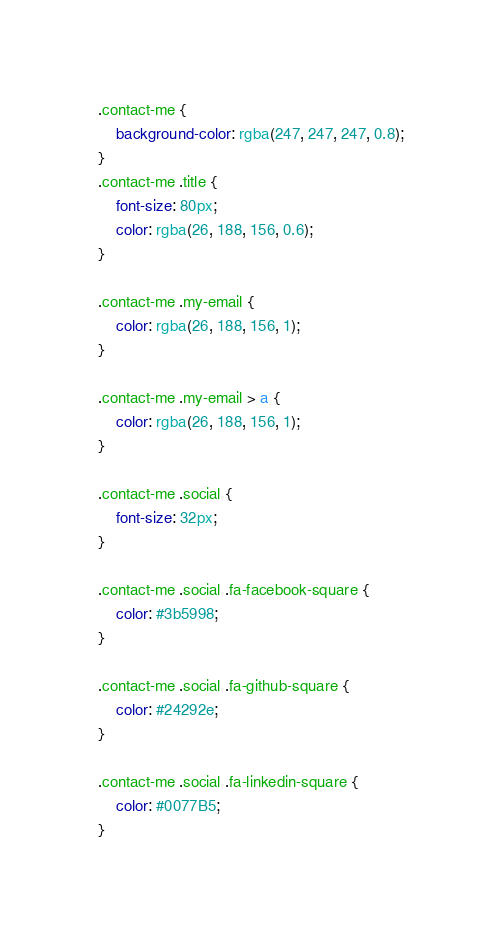<code> <loc_0><loc_0><loc_500><loc_500><_CSS_>.contact-me {
    background-color: rgba(247, 247, 247, 0.8);
}
.contact-me .title {
    font-size: 80px;
    color: rgba(26, 188, 156, 0.6);
}

.contact-me .my-email {
    color: rgba(26, 188, 156, 1);
}

.contact-me .my-email > a {
    color: rgba(26, 188, 156, 1);
}

.contact-me .social {
    font-size: 32px;
}

.contact-me .social .fa-facebook-square {
    color: #3b5998;
}

.contact-me .social .fa-github-square {
    color: #24292e;
}

.contact-me .social .fa-linkedin-square {
    color: #0077B5;
}</code> 